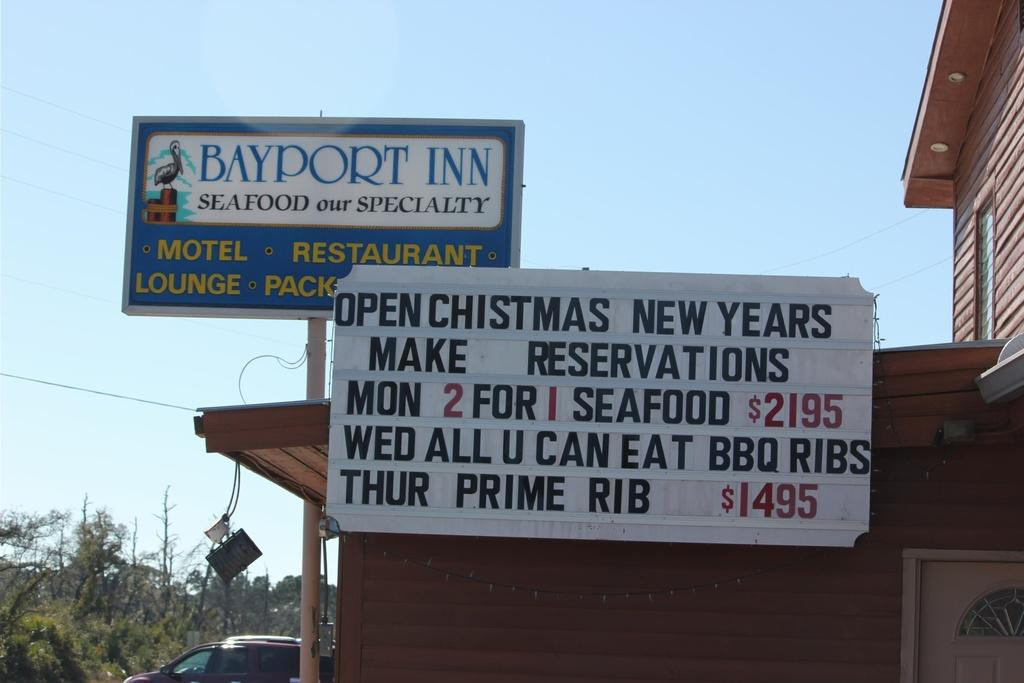<image>
Provide a brief description of the given image. An inn called Bayport Inn has a catchphrase that says "seafood our specialty." 